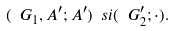Convert formula to latex. <formula><loc_0><loc_0><loc_500><loc_500>( \ G _ { 1 } , A ^ { \prime } ; A ^ { \prime } ) \ s i ( \ G ^ { \prime } _ { 2 } ; \cdot ) .</formula> 